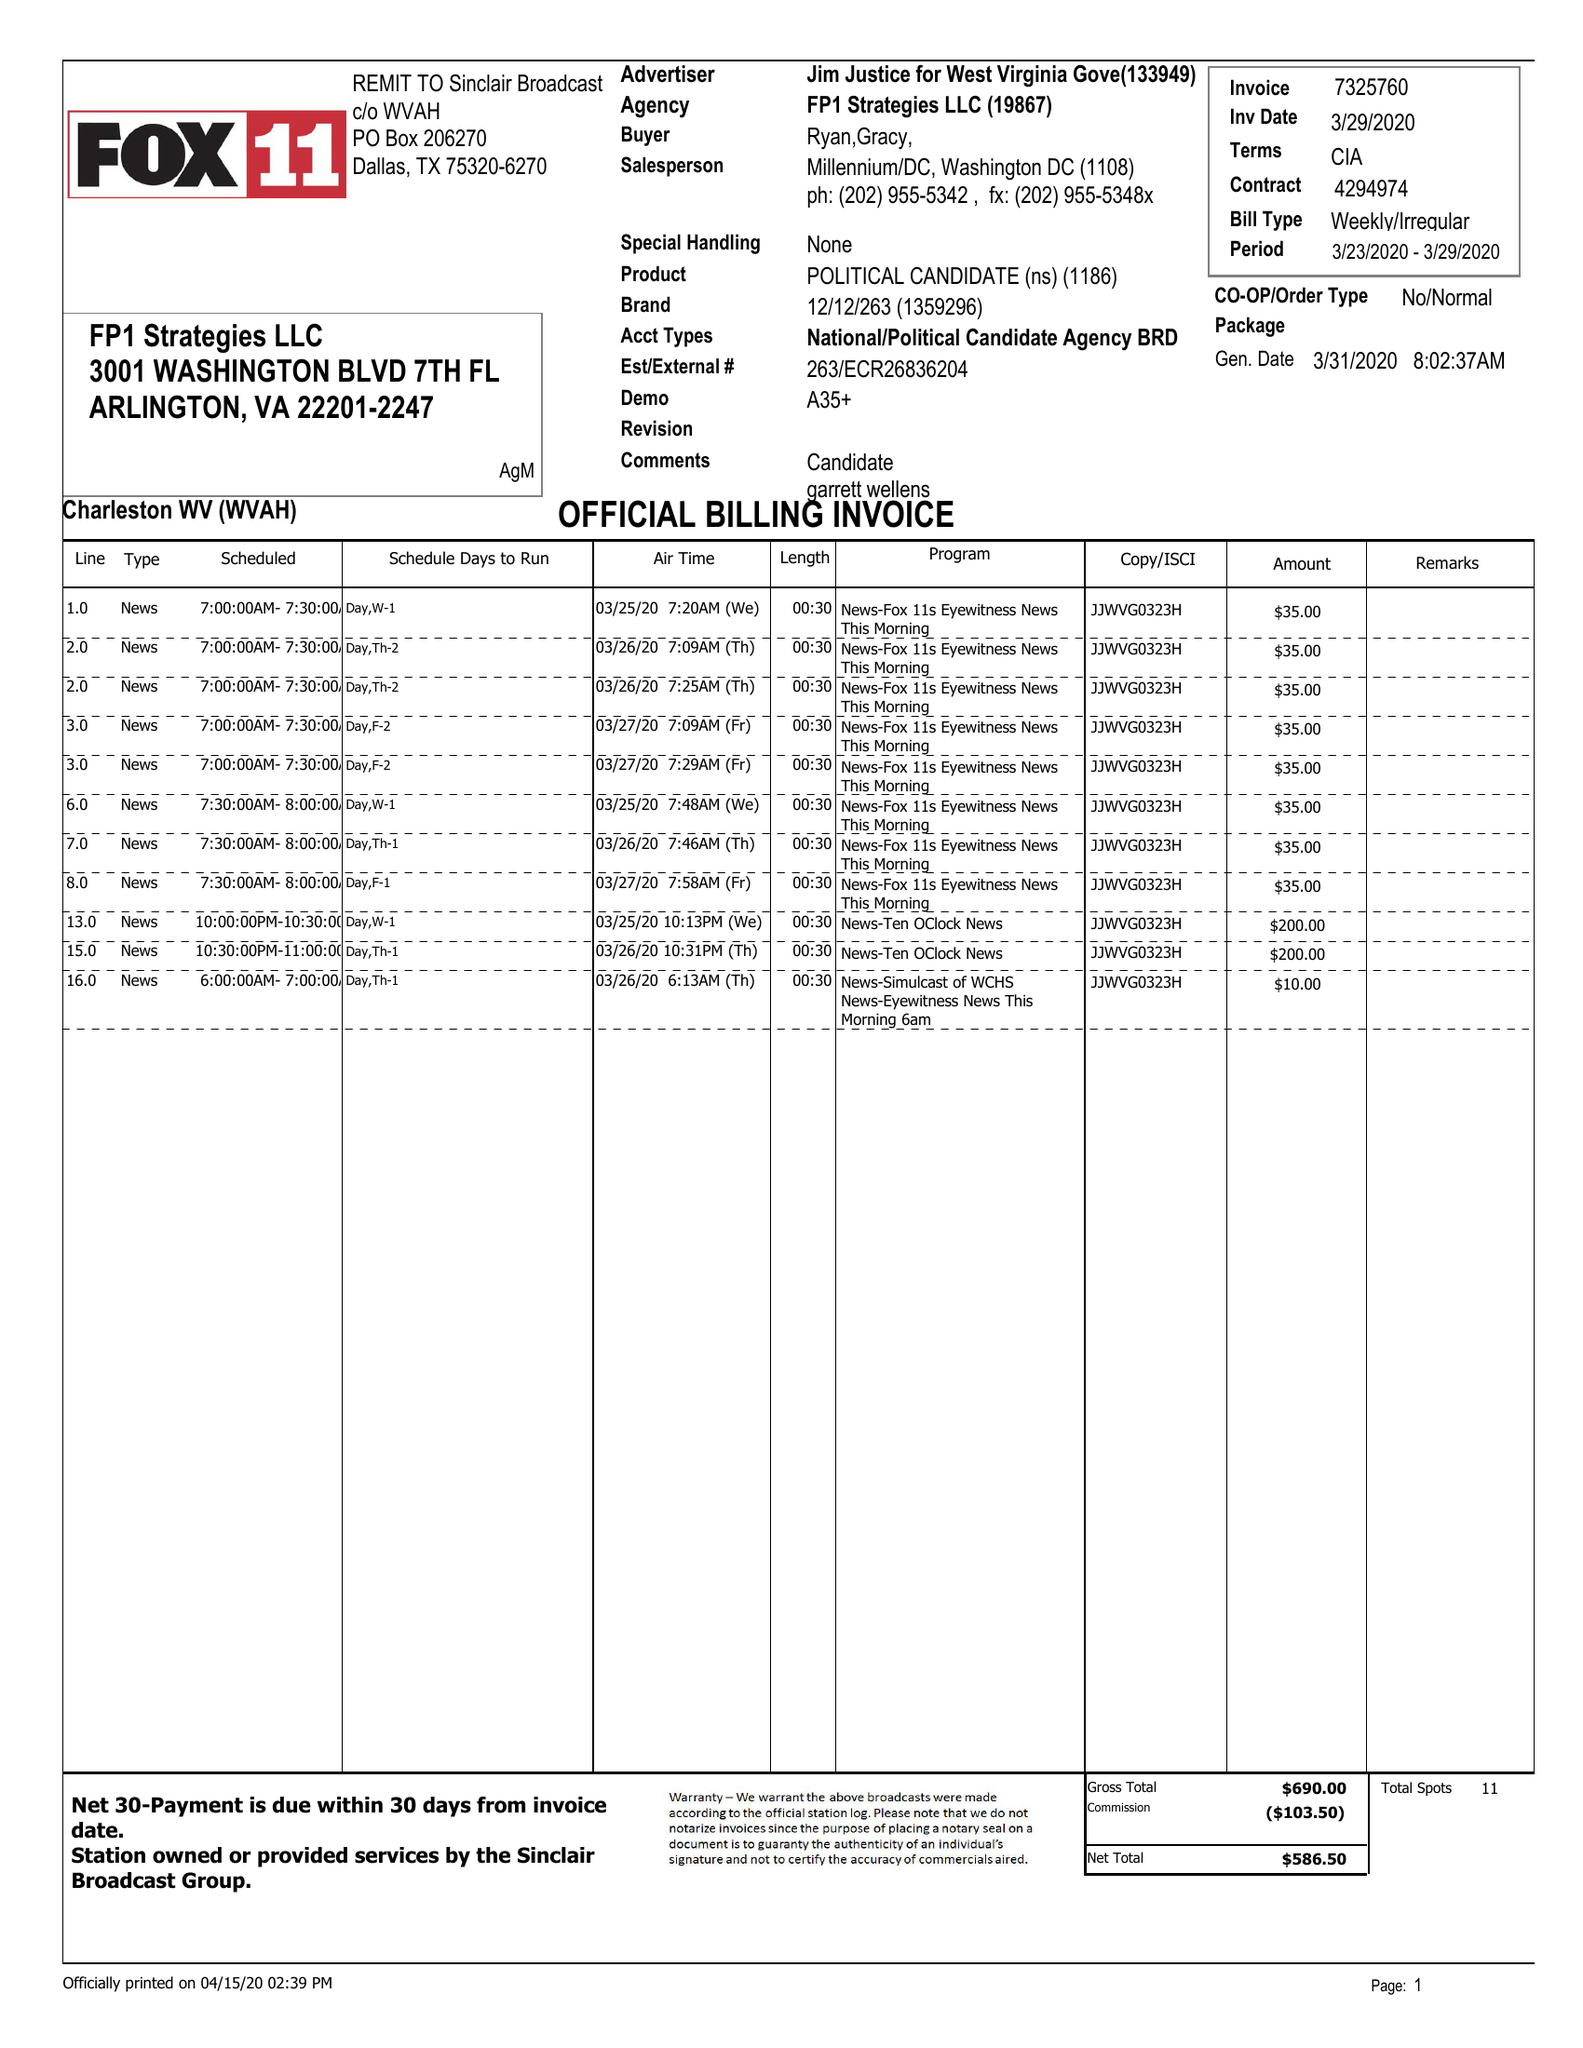What is the value for the contract_num?
Answer the question using a single word or phrase. 4294974 